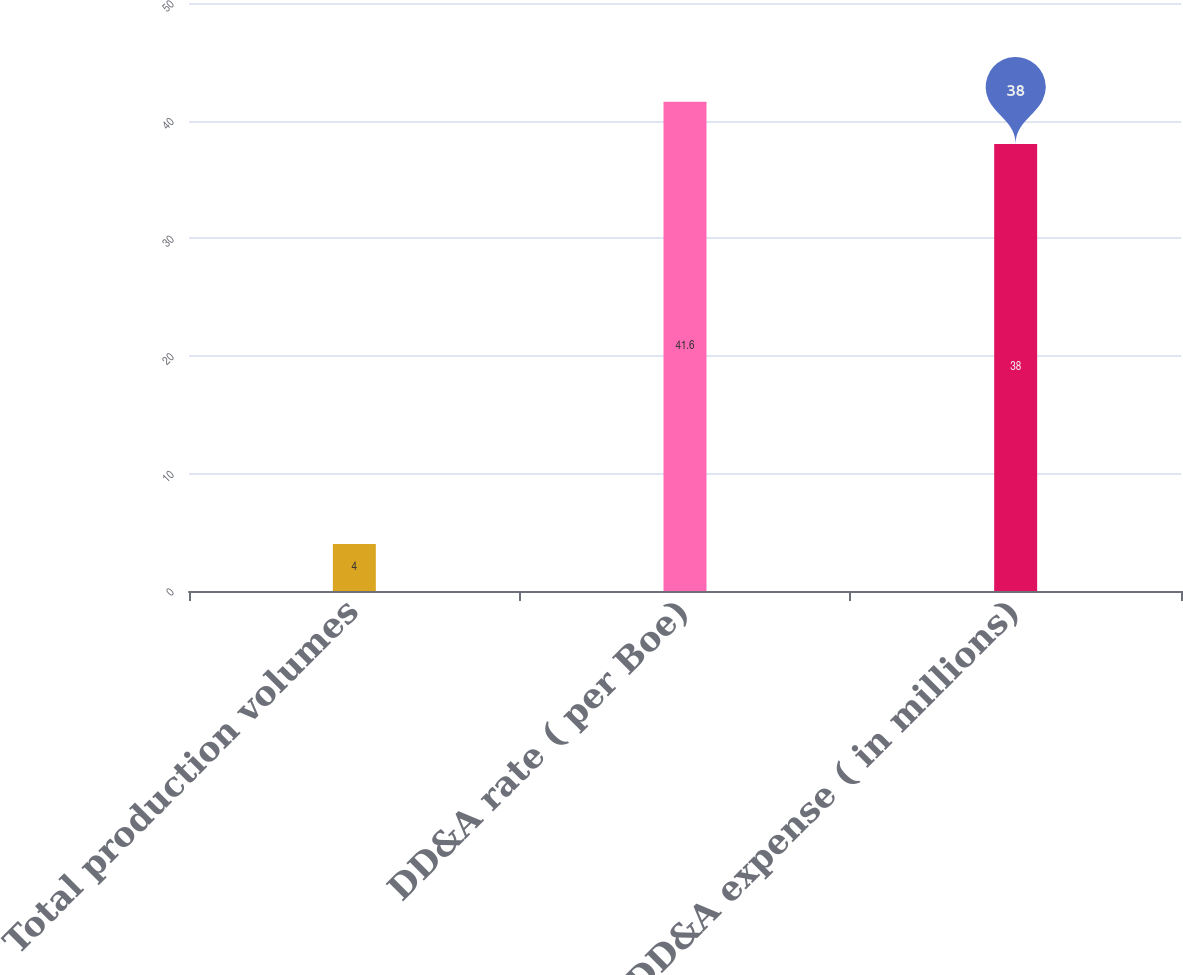<chart> <loc_0><loc_0><loc_500><loc_500><bar_chart><fcel>Total production volumes<fcel>DD&A rate ( per Boe)<fcel>DD&A expense ( in millions)<nl><fcel>4<fcel>41.6<fcel>38<nl></chart> 